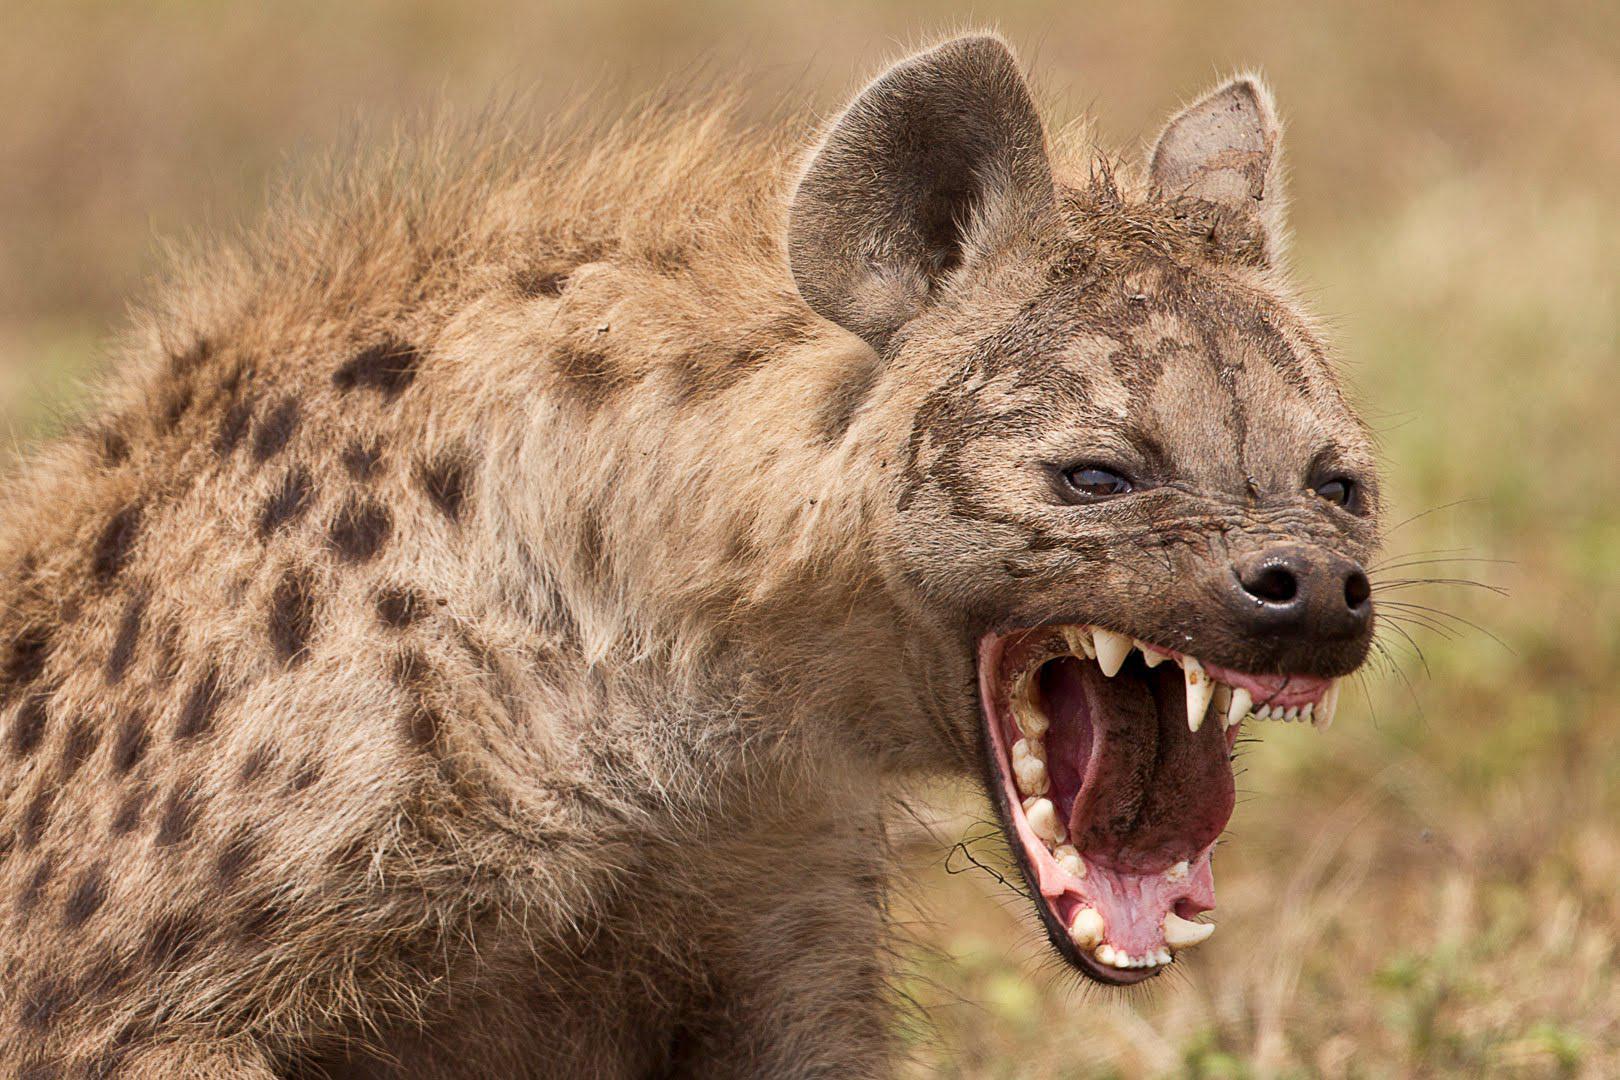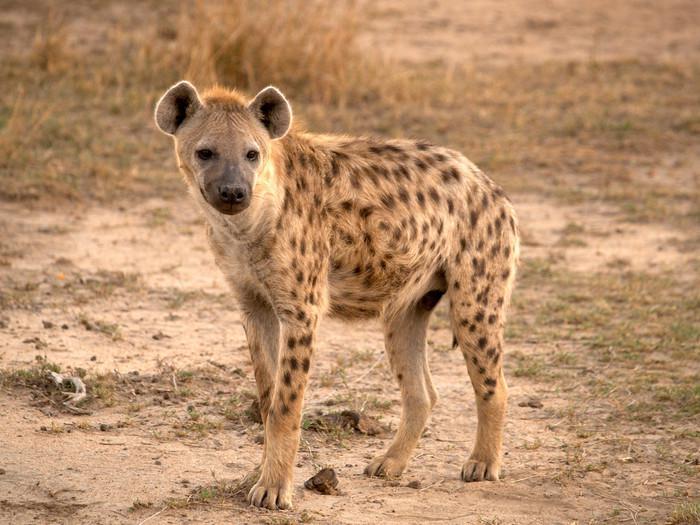The first image is the image on the left, the second image is the image on the right. Analyze the images presented: Is the assertion "An image shows a hyena carrying prey in its jaws." valid? Answer yes or no. No. 